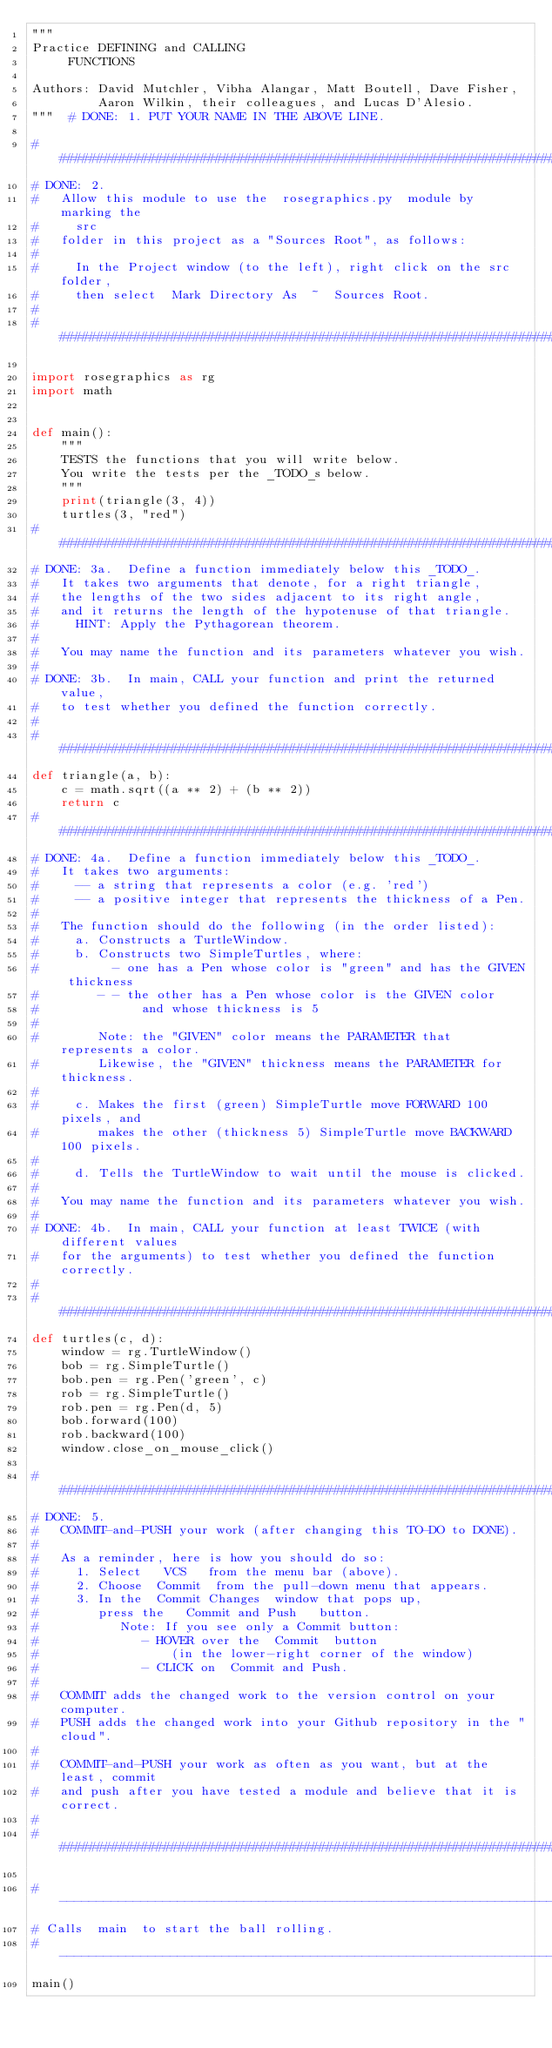Convert code to text. <code><loc_0><loc_0><loc_500><loc_500><_Python_>"""
Practice DEFINING and CALLING
     FUNCTIONS

Authors: David Mutchler, Vibha Alangar, Matt Boutell, Dave Fisher,
         Aaron Wilkin, their colleagues, and Lucas D'Alesio.
"""  # DONE: 1. PUT YOUR NAME IN THE ABOVE LINE.

###############################################################################
# DONE: 2.
#   Allow this module to use the  rosegraphics.py  module by marking the
#     src
#   folder in this project as a "Sources Root", as follows:
#
#     In the Project window (to the left), right click on the src  folder,
#     then select  Mark Directory As  ~  Sources Root.
#
###############################################################################

import rosegraphics as rg
import math


def main():
    """
    TESTS the functions that you will write below.
    You write the tests per the _TODO_s below.
    """
    print(triangle(3, 4))
    turtles(3, "red")
###############################################################################
# DONE: 3a.  Define a function immediately below this _TODO_.
#   It takes two arguments that denote, for a right triangle,
#   the lengths of the two sides adjacent to its right angle,
#   and it returns the length of the hypotenuse of that triangle.
#     HINT: Apply the Pythagorean theorem.
#
#   You may name the function and its parameters whatever you wish.
#
# DONE: 3b.  In main, CALL your function and print the returned value,
#   to test whether you defined the function correctly.
#
###############################################################################
def triangle(a, b):
    c = math.sqrt((a ** 2) + (b ** 2))
    return c
###############################################################################
# DONE: 4a.  Define a function immediately below this _TODO_.
#   It takes two arguments:
#     -- a string that represents a color (e.g. 'red')
#     -- a positive integer that represents the thickness of a Pen.
#
#   The function should do the following (in the order listed):
#     a. Constructs a TurtleWindow.
#     b. Constructs two SimpleTurtles, where:
#          - one has a Pen whose color is "green" and has the GIVEN thickness
#        - - the other has a Pen whose color is the GIVEN color
#              and whose thickness is 5
#
#        Note: the "GIVEN" color means the PARAMETER that represents a color.
#        Likewise, the "GIVEN" thickness means the PARAMETER for thickness.
#
#     c. Makes the first (green) SimpleTurtle move FORWARD 100 pixels, and
#        makes the other (thickness 5) SimpleTurtle move BACKWARD 100 pixels.
#
#     d. Tells the TurtleWindow to wait until the mouse is clicked.
#
#   You may name the function and its parameters whatever you wish.
#
# DONE: 4b.  In main, CALL your function at least TWICE (with different values
#   for the arguments) to test whether you defined the function correctly.
#
###############################################################################
def turtles(c, d):
    window = rg.TurtleWindow()
    bob = rg.SimpleTurtle()
    bob.pen = rg.Pen('green', c)
    rob = rg.SimpleTurtle()
    rob.pen = rg.Pen(d, 5)
    bob.forward(100)
    rob.backward(100)
    window.close_on_mouse_click()

###############################################################################
# DONE: 5.
#   COMMIT-and-PUSH your work (after changing this TO-DO to DONE).
#
#   As a reminder, here is how you should do so:
#     1. Select   VCS   from the menu bar (above).
#     2. Choose  Commit  from the pull-down menu that appears.
#     3. In the  Commit Changes  window that pops up,
#        press the   Commit and Push   button.
#           Note: If you see only a Commit button:
#              - HOVER over the  Commit  button
#                  (in the lower-right corner of the window)
#              - CLICK on  Commit and Push.
#
#   COMMIT adds the changed work to the version control on your computer.
#   PUSH adds the changed work into your Github repository in the "cloud".
#
#   COMMIT-and-PUSH your work as often as you want, but at the least, commit
#   and push after you have tested a module and believe that it is correct.
#
###############################################################################

# -----------------------------------------------------------------------------
# Calls  main  to start the ball rolling.
# -----------------------------------------------------------------------------
main()
</code> 